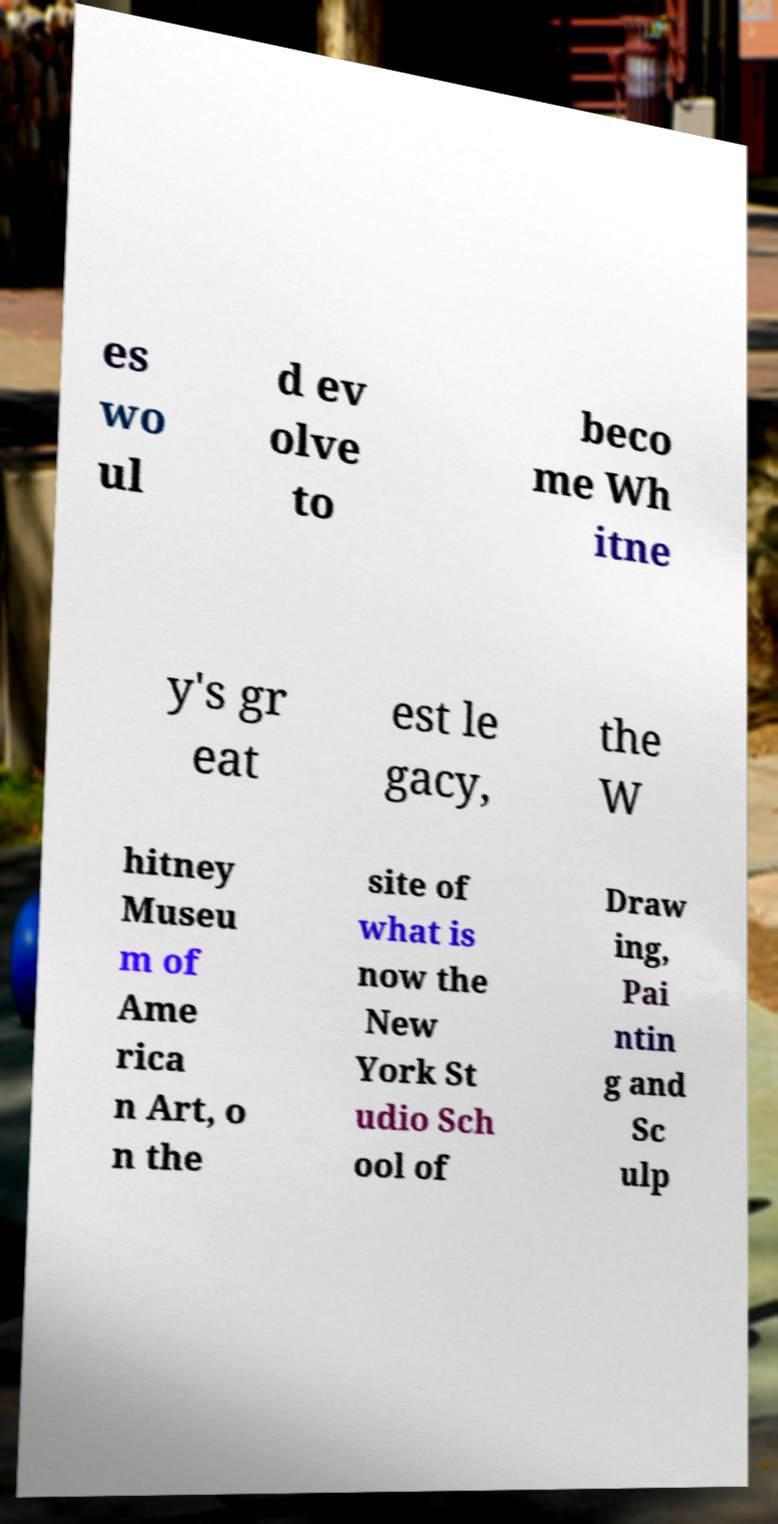Can you read and provide the text displayed in the image?This photo seems to have some interesting text. Can you extract and type it out for me? es wo ul d ev olve to beco me Wh itne y's gr eat est le gacy, the W hitney Museu m of Ame rica n Art, o n the site of what is now the New York St udio Sch ool of Draw ing, Pai ntin g and Sc ulp 